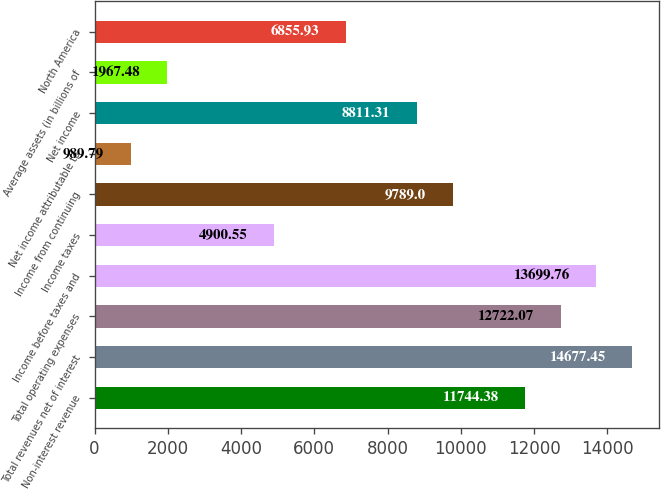<chart> <loc_0><loc_0><loc_500><loc_500><bar_chart><fcel>Non-interest revenue<fcel>Total revenues net of interest<fcel>Total operating expenses<fcel>Income before taxes and<fcel>Income taxes<fcel>Income from continuing<fcel>Net income attributable to<fcel>Net income<fcel>Average assets (in billions of<fcel>North America<nl><fcel>11744.4<fcel>14677.5<fcel>12722.1<fcel>13699.8<fcel>4900.55<fcel>9789<fcel>989.79<fcel>8811.31<fcel>1967.48<fcel>6855.93<nl></chart> 